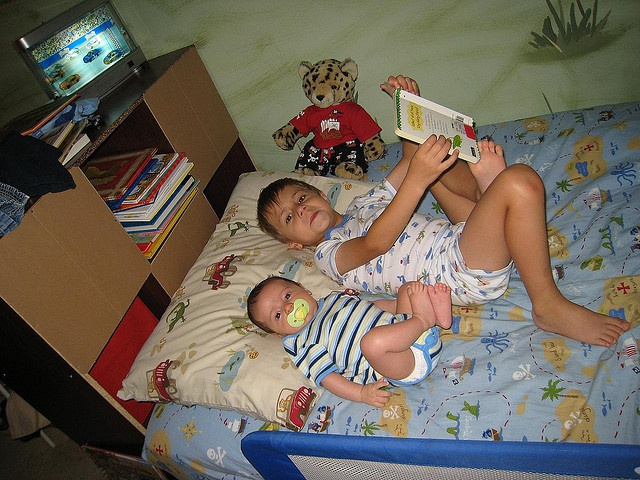Describe the objects in this image and their specific colors. I can see bed in black, darkgray, gray, and tan tones, people in black, salmon, brown, lightgray, and darkgray tones, people in black, salmon, lightgray, and darkgray tones, tv in black, gray, lightblue, and ivory tones, and teddy bear in black, maroon, olive, and gray tones in this image. 